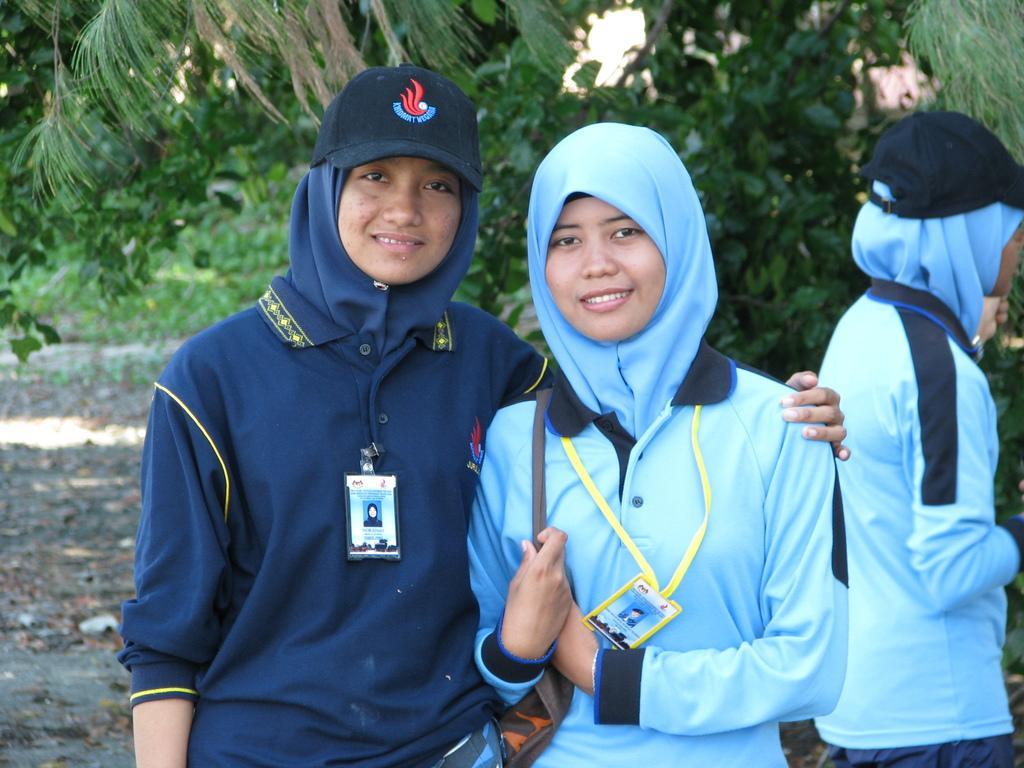Could you give a brief overview of what you see in this image? This picture describes about group of people, few people wore badges, behind to them we can see few trees. 